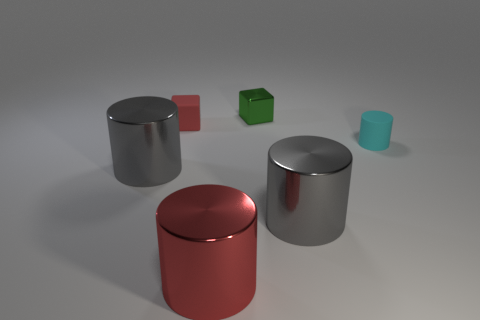Subtract 1 cylinders. How many cylinders are left? 3 Subtract all red cylinders. How many cylinders are left? 3 Add 2 small cyan cylinders. How many objects exist? 8 Subtract all yellow cylinders. Subtract all gray blocks. How many cylinders are left? 4 Subtract all cubes. How many objects are left? 4 Add 1 tiny cyan cylinders. How many tiny cyan cylinders exist? 2 Subtract 1 red cylinders. How many objects are left? 5 Subtract all metallic cylinders. Subtract all tiny matte cylinders. How many objects are left? 2 Add 5 cylinders. How many cylinders are left? 9 